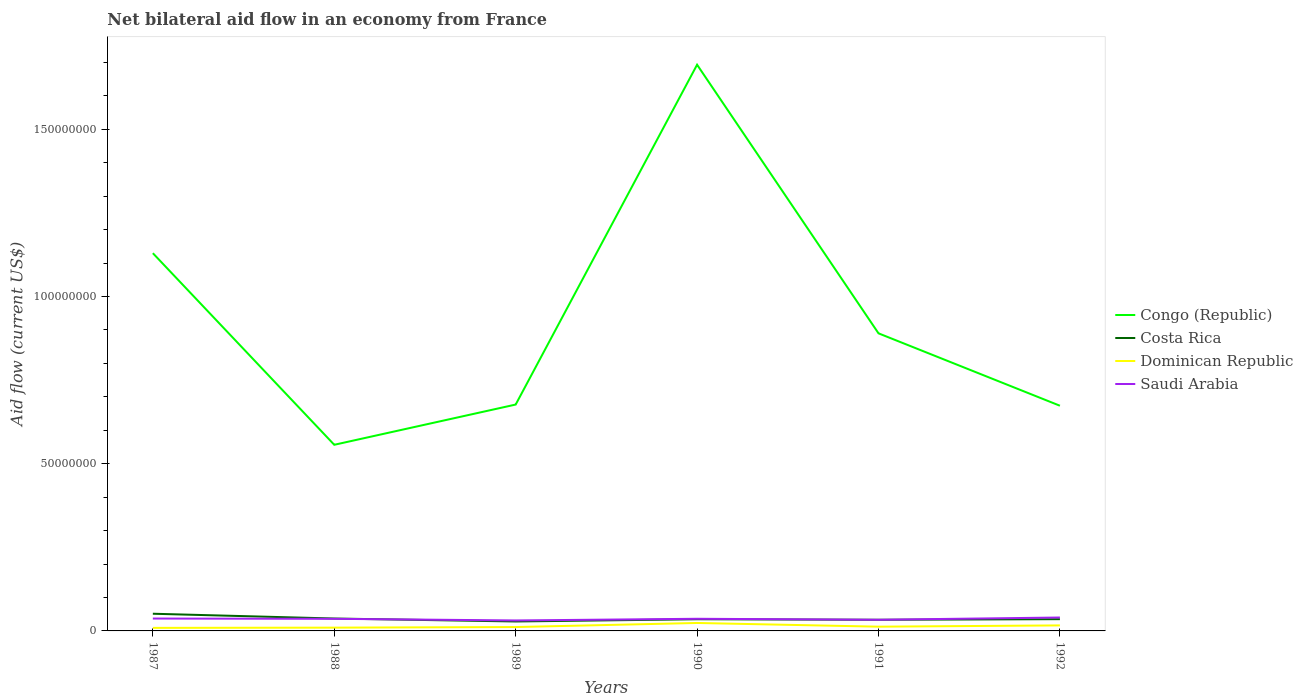Does the line corresponding to Dominican Republic intersect with the line corresponding to Costa Rica?
Keep it short and to the point. No. Across all years, what is the maximum net bilateral aid flow in Costa Rica?
Offer a terse response. 2.82e+06. What is the total net bilateral aid flow in Congo (Republic) in the graph?
Your answer should be very brief. 4.56e+07. What is the difference between the highest and the second highest net bilateral aid flow in Congo (Republic)?
Give a very brief answer. 1.14e+08. Is the net bilateral aid flow in Congo (Republic) strictly greater than the net bilateral aid flow in Costa Rica over the years?
Offer a terse response. No. How many years are there in the graph?
Offer a very short reply. 6. What is the difference between two consecutive major ticks on the Y-axis?
Provide a succinct answer. 5.00e+07. Are the values on the major ticks of Y-axis written in scientific E-notation?
Provide a succinct answer. No. Does the graph contain any zero values?
Make the answer very short. No. Does the graph contain grids?
Provide a succinct answer. No. How many legend labels are there?
Make the answer very short. 4. How are the legend labels stacked?
Offer a very short reply. Vertical. What is the title of the graph?
Your response must be concise. Net bilateral aid flow in an economy from France. What is the Aid flow (current US$) of Congo (Republic) in 1987?
Give a very brief answer. 1.13e+08. What is the Aid flow (current US$) in Costa Rica in 1987?
Ensure brevity in your answer.  5.14e+06. What is the Aid flow (current US$) in Dominican Republic in 1987?
Your answer should be compact. 9.10e+05. What is the Aid flow (current US$) of Saudi Arabia in 1987?
Provide a succinct answer. 3.70e+06. What is the Aid flow (current US$) of Congo (Republic) in 1988?
Give a very brief answer. 5.57e+07. What is the Aid flow (current US$) of Costa Rica in 1988?
Keep it short and to the point. 3.71e+06. What is the Aid flow (current US$) in Dominican Republic in 1988?
Make the answer very short. 9.80e+05. What is the Aid flow (current US$) of Saudi Arabia in 1988?
Offer a terse response. 3.62e+06. What is the Aid flow (current US$) of Congo (Republic) in 1989?
Ensure brevity in your answer.  6.77e+07. What is the Aid flow (current US$) of Costa Rica in 1989?
Your answer should be compact. 2.82e+06. What is the Aid flow (current US$) in Dominican Republic in 1989?
Offer a terse response. 1.16e+06. What is the Aid flow (current US$) of Saudi Arabia in 1989?
Your answer should be very brief. 3.13e+06. What is the Aid flow (current US$) of Congo (Republic) in 1990?
Your answer should be very brief. 1.69e+08. What is the Aid flow (current US$) of Costa Rica in 1990?
Offer a very short reply. 3.49e+06. What is the Aid flow (current US$) of Dominican Republic in 1990?
Provide a succinct answer. 2.38e+06. What is the Aid flow (current US$) of Saudi Arabia in 1990?
Provide a short and direct response. 3.63e+06. What is the Aid flow (current US$) in Congo (Republic) in 1991?
Your answer should be very brief. 8.90e+07. What is the Aid flow (current US$) of Costa Rica in 1991?
Provide a short and direct response. 3.33e+06. What is the Aid flow (current US$) of Dominican Republic in 1991?
Your response must be concise. 1.27e+06. What is the Aid flow (current US$) in Saudi Arabia in 1991?
Your response must be concise. 3.34e+06. What is the Aid flow (current US$) of Congo (Republic) in 1992?
Your response must be concise. 6.73e+07. What is the Aid flow (current US$) of Costa Rica in 1992?
Ensure brevity in your answer.  3.52e+06. What is the Aid flow (current US$) in Dominican Republic in 1992?
Keep it short and to the point. 1.65e+06. What is the Aid flow (current US$) of Saudi Arabia in 1992?
Your answer should be compact. 4.01e+06. Across all years, what is the maximum Aid flow (current US$) of Congo (Republic)?
Offer a very short reply. 1.69e+08. Across all years, what is the maximum Aid flow (current US$) of Costa Rica?
Provide a succinct answer. 5.14e+06. Across all years, what is the maximum Aid flow (current US$) of Dominican Republic?
Provide a succinct answer. 2.38e+06. Across all years, what is the maximum Aid flow (current US$) in Saudi Arabia?
Offer a terse response. 4.01e+06. Across all years, what is the minimum Aid flow (current US$) of Congo (Republic)?
Provide a succinct answer. 5.57e+07. Across all years, what is the minimum Aid flow (current US$) of Costa Rica?
Your response must be concise. 2.82e+06. Across all years, what is the minimum Aid flow (current US$) in Dominican Republic?
Ensure brevity in your answer.  9.10e+05. Across all years, what is the minimum Aid flow (current US$) in Saudi Arabia?
Provide a succinct answer. 3.13e+06. What is the total Aid flow (current US$) of Congo (Republic) in the graph?
Give a very brief answer. 5.62e+08. What is the total Aid flow (current US$) of Costa Rica in the graph?
Ensure brevity in your answer.  2.20e+07. What is the total Aid flow (current US$) in Dominican Republic in the graph?
Offer a terse response. 8.35e+06. What is the total Aid flow (current US$) in Saudi Arabia in the graph?
Ensure brevity in your answer.  2.14e+07. What is the difference between the Aid flow (current US$) of Congo (Republic) in 1987 and that in 1988?
Offer a terse response. 5.73e+07. What is the difference between the Aid flow (current US$) of Costa Rica in 1987 and that in 1988?
Provide a short and direct response. 1.43e+06. What is the difference between the Aid flow (current US$) of Saudi Arabia in 1987 and that in 1988?
Give a very brief answer. 8.00e+04. What is the difference between the Aid flow (current US$) in Congo (Republic) in 1987 and that in 1989?
Offer a very short reply. 4.53e+07. What is the difference between the Aid flow (current US$) of Costa Rica in 1987 and that in 1989?
Ensure brevity in your answer.  2.32e+06. What is the difference between the Aid flow (current US$) in Saudi Arabia in 1987 and that in 1989?
Offer a very short reply. 5.70e+05. What is the difference between the Aid flow (current US$) of Congo (Republic) in 1987 and that in 1990?
Your answer should be very brief. -5.64e+07. What is the difference between the Aid flow (current US$) of Costa Rica in 1987 and that in 1990?
Ensure brevity in your answer.  1.65e+06. What is the difference between the Aid flow (current US$) of Dominican Republic in 1987 and that in 1990?
Offer a very short reply. -1.47e+06. What is the difference between the Aid flow (current US$) of Congo (Republic) in 1987 and that in 1991?
Give a very brief answer. 2.40e+07. What is the difference between the Aid flow (current US$) of Costa Rica in 1987 and that in 1991?
Your answer should be very brief. 1.81e+06. What is the difference between the Aid flow (current US$) of Dominican Republic in 1987 and that in 1991?
Keep it short and to the point. -3.60e+05. What is the difference between the Aid flow (current US$) in Saudi Arabia in 1987 and that in 1991?
Offer a terse response. 3.60e+05. What is the difference between the Aid flow (current US$) in Congo (Republic) in 1987 and that in 1992?
Keep it short and to the point. 4.56e+07. What is the difference between the Aid flow (current US$) in Costa Rica in 1987 and that in 1992?
Provide a succinct answer. 1.62e+06. What is the difference between the Aid flow (current US$) in Dominican Republic in 1987 and that in 1992?
Your answer should be compact. -7.40e+05. What is the difference between the Aid flow (current US$) of Saudi Arabia in 1987 and that in 1992?
Give a very brief answer. -3.10e+05. What is the difference between the Aid flow (current US$) in Congo (Republic) in 1988 and that in 1989?
Provide a short and direct response. -1.20e+07. What is the difference between the Aid flow (current US$) in Costa Rica in 1988 and that in 1989?
Offer a terse response. 8.90e+05. What is the difference between the Aid flow (current US$) of Dominican Republic in 1988 and that in 1989?
Offer a terse response. -1.80e+05. What is the difference between the Aid flow (current US$) in Congo (Republic) in 1988 and that in 1990?
Give a very brief answer. -1.14e+08. What is the difference between the Aid flow (current US$) in Costa Rica in 1988 and that in 1990?
Make the answer very short. 2.20e+05. What is the difference between the Aid flow (current US$) of Dominican Republic in 1988 and that in 1990?
Provide a short and direct response. -1.40e+06. What is the difference between the Aid flow (current US$) of Congo (Republic) in 1988 and that in 1991?
Ensure brevity in your answer.  -3.33e+07. What is the difference between the Aid flow (current US$) in Congo (Republic) in 1988 and that in 1992?
Offer a terse response. -1.17e+07. What is the difference between the Aid flow (current US$) in Costa Rica in 1988 and that in 1992?
Your answer should be compact. 1.90e+05. What is the difference between the Aid flow (current US$) in Dominican Republic in 1988 and that in 1992?
Ensure brevity in your answer.  -6.70e+05. What is the difference between the Aid flow (current US$) in Saudi Arabia in 1988 and that in 1992?
Ensure brevity in your answer.  -3.90e+05. What is the difference between the Aid flow (current US$) of Congo (Republic) in 1989 and that in 1990?
Your answer should be compact. -1.02e+08. What is the difference between the Aid flow (current US$) of Costa Rica in 1989 and that in 1990?
Provide a short and direct response. -6.70e+05. What is the difference between the Aid flow (current US$) of Dominican Republic in 1989 and that in 1990?
Provide a short and direct response. -1.22e+06. What is the difference between the Aid flow (current US$) in Saudi Arabia in 1989 and that in 1990?
Provide a short and direct response. -5.00e+05. What is the difference between the Aid flow (current US$) of Congo (Republic) in 1989 and that in 1991?
Keep it short and to the point. -2.13e+07. What is the difference between the Aid flow (current US$) of Costa Rica in 1989 and that in 1991?
Offer a very short reply. -5.10e+05. What is the difference between the Aid flow (current US$) in Congo (Republic) in 1989 and that in 1992?
Make the answer very short. 3.50e+05. What is the difference between the Aid flow (current US$) of Costa Rica in 1989 and that in 1992?
Offer a terse response. -7.00e+05. What is the difference between the Aid flow (current US$) of Dominican Republic in 1989 and that in 1992?
Make the answer very short. -4.90e+05. What is the difference between the Aid flow (current US$) of Saudi Arabia in 1989 and that in 1992?
Your answer should be compact. -8.80e+05. What is the difference between the Aid flow (current US$) in Congo (Republic) in 1990 and that in 1991?
Keep it short and to the point. 8.03e+07. What is the difference between the Aid flow (current US$) in Dominican Republic in 1990 and that in 1991?
Provide a succinct answer. 1.11e+06. What is the difference between the Aid flow (current US$) of Congo (Republic) in 1990 and that in 1992?
Your response must be concise. 1.02e+08. What is the difference between the Aid flow (current US$) in Dominican Republic in 1990 and that in 1992?
Keep it short and to the point. 7.30e+05. What is the difference between the Aid flow (current US$) of Saudi Arabia in 1990 and that in 1992?
Your response must be concise. -3.80e+05. What is the difference between the Aid flow (current US$) in Congo (Republic) in 1991 and that in 1992?
Give a very brief answer. 2.16e+07. What is the difference between the Aid flow (current US$) in Costa Rica in 1991 and that in 1992?
Ensure brevity in your answer.  -1.90e+05. What is the difference between the Aid flow (current US$) of Dominican Republic in 1991 and that in 1992?
Keep it short and to the point. -3.80e+05. What is the difference between the Aid flow (current US$) in Saudi Arabia in 1991 and that in 1992?
Offer a terse response. -6.70e+05. What is the difference between the Aid flow (current US$) of Congo (Republic) in 1987 and the Aid flow (current US$) of Costa Rica in 1988?
Ensure brevity in your answer.  1.09e+08. What is the difference between the Aid flow (current US$) of Congo (Republic) in 1987 and the Aid flow (current US$) of Dominican Republic in 1988?
Give a very brief answer. 1.12e+08. What is the difference between the Aid flow (current US$) in Congo (Republic) in 1987 and the Aid flow (current US$) in Saudi Arabia in 1988?
Provide a short and direct response. 1.09e+08. What is the difference between the Aid flow (current US$) in Costa Rica in 1987 and the Aid flow (current US$) in Dominican Republic in 1988?
Ensure brevity in your answer.  4.16e+06. What is the difference between the Aid flow (current US$) of Costa Rica in 1987 and the Aid flow (current US$) of Saudi Arabia in 1988?
Your response must be concise. 1.52e+06. What is the difference between the Aid flow (current US$) of Dominican Republic in 1987 and the Aid flow (current US$) of Saudi Arabia in 1988?
Provide a succinct answer. -2.71e+06. What is the difference between the Aid flow (current US$) of Congo (Republic) in 1987 and the Aid flow (current US$) of Costa Rica in 1989?
Make the answer very short. 1.10e+08. What is the difference between the Aid flow (current US$) in Congo (Republic) in 1987 and the Aid flow (current US$) in Dominican Republic in 1989?
Keep it short and to the point. 1.12e+08. What is the difference between the Aid flow (current US$) in Congo (Republic) in 1987 and the Aid flow (current US$) in Saudi Arabia in 1989?
Offer a very short reply. 1.10e+08. What is the difference between the Aid flow (current US$) in Costa Rica in 1987 and the Aid flow (current US$) in Dominican Republic in 1989?
Your response must be concise. 3.98e+06. What is the difference between the Aid flow (current US$) in Costa Rica in 1987 and the Aid flow (current US$) in Saudi Arabia in 1989?
Ensure brevity in your answer.  2.01e+06. What is the difference between the Aid flow (current US$) in Dominican Republic in 1987 and the Aid flow (current US$) in Saudi Arabia in 1989?
Offer a terse response. -2.22e+06. What is the difference between the Aid flow (current US$) in Congo (Republic) in 1987 and the Aid flow (current US$) in Costa Rica in 1990?
Ensure brevity in your answer.  1.09e+08. What is the difference between the Aid flow (current US$) in Congo (Republic) in 1987 and the Aid flow (current US$) in Dominican Republic in 1990?
Give a very brief answer. 1.11e+08. What is the difference between the Aid flow (current US$) of Congo (Republic) in 1987 and the Aid flow (current US$) of Saudi Arabia in 1990?
Your response must be concise. 1.09e+08. What is the difference between the Aid flow (current US$) in Costa Rica in 1987 and the Aid flow (current US$) in Dominican Republic in 1990?
Your response must be concise. 2.76e+06. What is the difference between the Aid flow (current US$) in Costa Rica in 1987 and the Aid flow (current US$) in Saudi Arabia in 1990?
Your response must be concise. 1.51e+06. What is the difference between the Aid flow (current US$) of Dominican Republic in 1987 and the Aid flow (current US$) of Saudi Arabia in 1990?
Offer a terse response. -2.72e+06. What is the difference between the Aid flow (current US$) in Congo (Republic) in 1987 and the Aid flow (current US$) in Costa Rica in 1991?
Your answer should be very brief. 1.10e+08. What is the difference between the Aid flow (current US$) of Congo (Republic) in 1987 and the Aid flow (current US$) of Dominican Republic in 1991?
Your answer should be very brief. 1.12e+08. What is the difference between the Aid flow (current US$) in Congo (Republic) in 1987 and the Aid flow (current US$) in Saudi Arabia in 1991?
Make the answer very short. 1.10e+08. What is the difference between the Aid flow (current US$) of Costa Rica in 1987 and the Aid flow (current US$) of Dominican Republic in 1991?
Give a very brief answer. 3.87e+06. What is the difference between the Aid flow (current US$) in Costa Rica in 1987 and the Aid flow (current US$) in Saudi Arabia in 1991?
Ensure brevity in your answer.  1.80e+06. What is the difference between the Aid flow (current US$) of Dominican Republic in 1987 and the Aid flow (current US$) of Saudi Arabia in 1991?
Provide a short and direct response. -2.43e+06. What is the difference between the Aid flow (current US$) of Congo (Republic) in 1987 and the Aid flow (current US$) of Costa Rica in 1992?
Offer a very short reply. 1.09e+08. What is the difference between the Aid flow (current US$) of Congo (Republic) in 1987 and the Aid flow (current US$) of Dominican Republic in 1992?
Your answer should be compact. 1.11e+08. What is the difference between the Aid flow (current US$) in Congo (Republic) in 1987 and the Aid flow (current US$) in Saudi Arabia in 1992?
Provide a short and direct response. 1.09e+08. What is the difference between the Aid flow (current US$) of Costa Rica in 1987 and the Aid flow (current US$) of Dominican Republic in 1992?
Give a very brief answer. 3.49e+06. What is the difference between the Aid flow (current US$) of Costa Rica in 1987 and the Aid flow (current US$) of Saudi Arabia in 1992?
Your response must be concise. 1.13e+06. What is the difference between the Aid flow (current US$) in Dominican Republic in 1987 and the Aid flow (current US$) in Saudi Arabia in 1992?
Offer a terse response. -3.10e+06. What is the difference between the Aid flow (current US$) in Congo (Republic) in 1988 and the Aid flow (current US$) in Costa Rica in 1989?
Make the answer very short. 5.28e+07. What is the difference between the Aid flow (current US$) of Congo (Republic) in 1988 and the Aid flow (current US$) of Dominican Republic in 1989?
Offer a very short reply. 5.45e+07. What is the difference between the Aid flow (current US$) in Congo (Republic) in 1988 and the Aid flow (current US$) in Saudi Arabia in 1989?
Your response must be concise. 5.25e+07. What is the difference between the Aid flow (current US$) of Costa Rica in 1988 and the Aid flow (current US$) of Dominican Republic in 1989?
Provide a short and direct response. 2.55e+06. What is the difference between the Aid flow (current US$) of Costa Rica in 1988 and the Aid flow (current US$) of Saudi Arabia in 1989?
Give a very brief answer. 5.80e+05. What is the difference between the Aid flow (current US$) of Dominican Republic in 1988 and the Aid flow (current US$) of Saudi Arabia in 1989?
Your response must be concise. -2.15e+06. What is the difference between the Aid flow (current US$) of Congo (Republic) in 1988 and the Aid flow (current US$) of Costa Rica in 1990?
Ensure brevity in your answer.  5.22e+07. What is the difference between the Aid flow (current US$) of Congo (Republic) in 1988 and the Aid flow (current US$) of Dominican Republic in 1990?
Provide a short and direct response. 5.33e+07. What is the difference between the Aid flow (current US$) of Congo (Republic) in 1988 and the Aid flow (current US$) of Saudi Arabia in 1990?
Keep it short and to the point. 5.20e+07. What is the difference between the Aid flow (current US$) of Costa Rica in 1988 and the Aid flow (current US$) of Dominican Republic in 1990?
Offer a terse response. 1.33e+06. What is the difference between the Aid flow (current US$) in Dominican Republic in 1988 and the Aid flow (current US$) in Saudi Arabia in 1990?
Give a very brief answer. -2.65e+06. What is the difference between the Aid flow (current US$) of Congo (Republic) in 1988 and the Aid flow (current US$) of Costa Rica in 1991?
Your answer should be compact. 5.23e+07. What is the difference between the Aid flow (current US$) in Congo (Republic) in 1988 and the Aid flow (current US$) in Dominican Republic in 1991?
Provide a succinct answer. 5.44e+07. What is the difference between the Aid flow (current US$) of Congo (Republic) in 1988 and the Aid flow (current US$) of Saudi Arabia in 1991?
Your response must be concise. 5.23e+07. What is the difference between the Aid flow (current US$) of Costa Rica in 1988 and the Aid flow (current US$) of Dominican Republic in 1991?
Ensure brevity in your answer.  2.44e+06. What is the difference between the Aid flow (current US$) in Costa Rica in 1988 and the Aid flow (current US$) in Saudi Arabia in 1991?
Offer a very short reply. 3.70e+05. What is the difference between the Aid flow (current US$) of Dominican Republic in 1988 and the Aid flow (current US$) of Saudi Arabia in 1991?
Offer a terse response. -2.36e+06. What is the difference between the Aid flow (current US$) of Congo (Republic) in 1988 and the Aid flow (current US$) of Costa Rica in 1992?
Offer a very short reply. 5.21e+07. What is the difference between the Aid flow (current US$) in Congo (Republic) in 1988 and the Aid flow (current US$) in Dominican Republic in 1992?
Your answer should be very brief. 5.40e+07. What is the difference between the Aid flow (current US$) in Congo (Republic) in 1988 and the Aid flow (current US$) in Saudi Arabia in 1992?
Offer a very short reply. 5.16e+07. What is the difference between the Aid flow (current US$) of Costa Rica in 1988 and the Aid flow (current US$) of Dominican Republic in 1992?
Give a very brief answer. 2.06e+06. What is the difference between the Aid flow (current US$) of Dominican Republic in 1988 and the Aid flow (current US$) of Saudi Arabia in 1992?
Your response must be concise. -3.03e+06. What is the difference between the Aid flow (current US$) in Congo (Republic) in 1989 and the Aid flow (current US$) in Costa Rica in 1990?
Give a very brief answer. 6.42e+07. What is the difference between the Aid flow (current US$) in Congo (Republic) in 1989 and the Aid flow (current US$) in Dominican Republic in 1990?
Ensure brevity in your answer.  6.53e+07. What is the difference between the Aid flow (current US$) of Congo (Republic) in 1989 and the Aid flow (current US$) of Saudi Arabia in 1990?
Offer a terse response. 6.41e+07. What is the difference between the Aid flow (current US$) of Costa Rica in 1989 and the Aid flow (current US$) of Dominican Republic in 1990?
Offer a very short reply. 4.40e+05. What is the difference between the Aid flow (current US$) of Costa Rica in 1989 and the Aid flow (current US$) of Saudi Arabia in 1990?
Your response must be concise. -8.10e+05. What is the difference between the Aid flow (current US$) in Dominican Republic in 1989 and the Aid flow (current US$) in Saudi Arabia in 1990?
Your answer should be very brief. -2.47e+06. What is the difference between the Aid flow (current US$) of Congo (Republic) in 1989 and the Aid flow (current US$) of Costa Rica in 1991?
Your answer should be very brief. 6.44e+07. What is the difference between the Aid flow (current US$) of Congo (Republic) in 1989 and the Aid flow (current US$) of Dominican Republic in 1991?
Give a very brief answer. 6.64e+07. What is the difference between the Aid flow (current US$) of Congo (Republic) in 1989 and the Aid flow (current US$) of Saudi Arabia in 1991?
Offer a terse response. 6.44e+07. What is the difference between the Aid flow (current US$) of Costa Rica in 1989 and the Aid flow (current US$) of Dominican Republic in 1991?
Ensure brevity in your answer.  1.55e+06. What is the difference between the Aid flow (current US$) of Costa Rica in 1989 and the Aid flow (current US$) of Saudi Arabia in 1991?
Give a very brief answer. -5.20e+05. What is the difference between the Aid flow (current US$) in Dominican Republic in 1989 and the Aid flow (current US$) in Saudi Arabia in 1991?
Give a very brief answer. -2.18e+06. What is the difference between the Aid flow (current US$) of Congo (Republic) in 1989 and the Aid flow (current US$) of Costa Rica in 1992?
Give a very brief answer. 6.42e+07. What is the difference between the Aid flow (current US$) in Congo (Republic) in 1989 and the Aid flow (current US$) in Dominican Republic in 1992?
Ensure brevity in your answer.  6.60e+07. What is the difference between the Aid flow (current US$) in Congo (Republic) in 1989 and the Aid flow (current US$) in Saudi Arabia in 1992?
Offer a very short reply. 6.37e+07. What is the difference between the Aid flow (current US$) in Costa Rica in 1989 and the Aid flow (current US$) in Dominican Republic in 1992?
Your answer should be very brief. 1.17e+06. What is the difference between the Aid flow (current US$) in Costa Rica in 1989 and the Aid flow (current US$) in Saudi Arabia in 1992?
Provide a short and direct response. -1.19e+06. What is the difference between the Aid flow (current US$) in Dominican Republic in 1989 and the Aid flow (current US$) in Saudi Arabia in 1992?
Keep it short and to the point. -2.85e+06. What is the difference between the Aid flow (current US$) in Congo (Republic) in 1990 and the Aid flow (current US$) in Costa Rica in 1991?
Your response must be concise. 1.66e+08. What is the difference between the Aid flow (current US$) in Congo (Republic) in 1990 and the Aid flow (current US$) in Dominican Republic in 1991?
Your answer should be compact. 1.68e+08. What is the difference between the Aid flow (current US$) of Congo (Republic) in 1990 and the Aid flow (current US$) of Saudi Arabia in 1991?
Provide a short and direct response. 1.66e+08. What is the difference between the Aid flow (current US$) of Costa Rica in 1990 and the Aid flow (current US$) of Dominican Republic in 1991?
Your answer should be compact. 2.22e+06. What is the difference between the Aid flow (current US$) of Costa Rica in 1990 and the Aid flow (current US$) of Saudi Arabia in 1991?
Keep it short and to the point. 1.50e+05. What is the difference between the Aid flow (current US$) in Dominican Republic in 1990 and the Aid flow (current US$) in Saudi Arabia in 1991?
Your answer should be compact. -9.60e+05. What is the difference between the Aid flow (current US$) in Congo (Republic) in 1990 and the Aid flow (current US$) in Costa Rica in 1992?
Your answer should be very brief. 1.66e+08. What is the difference between the Aid flow (current US$) in Congo (Republic) in 1990 and the Aid flow (current US$) in Dominican Republic in 1992?
Keep it short and to the point. 1.68e+08. What is the difference between the Aid flow (current US$) of Congo (Republic) in 1990 and the Aid flow (current US$) of Saudi Arabia in 1992?
Offer a very short reply. 1.65e+08. What is the difference between the Aid flow (current US$) of Costa Rica in 1990 and the Aid flow (current US$) of Dominican Republic in 1992?
Make the answer very short. 1.84e+06. What is the difference between the Aid flow (current US$) of Costa Rica in 1990 and the Aid flow (current US$) of Saudi Arabia in 1992?
Offer a very short reply. -5.20e+05. What is the difference between the Aid flow (current US$) in Dominican Republic in 1990 and the Aid flow (current US$) in Saudi Arabia in 1992?
Offer a terse response. -1.63e+06. What is the difference between the Aid flow (current US$) in Congo (Republic) in 1991 and the Aid flow (current US$) in Costa Rica in 1992?
Offer a very short reply. 8.55e+07. What is the difference between the Aid flow (current US$) of Congo (Republic) in 1991 and the Aid flow (current US$) of Dominican Republic in 1992?
Ensure brevity in your answer.  8.73e+07. What is the difference between the Aid flow (current US$) in Congo (Republic) in 1991 and the Aid flow (current US$) in Saudi Arabia in 1992?
Offer a terse response. 8.50e+07. What is the difference between the Aid flow (current US$) of Costa Rica in 1991 and the Aid flow (current US$) of Dominican Republic in 1992?
Give a very brief answer. 1.68e+06. What is the difference between the Aid flow (current US$) in Costa Rica in 1991 and the Aid flow (current US$) in Saudi Arabia in 1992?
Offer a very short reply. -6.80e+05. What is the difference between the Aid flow (current US$) in Dominican Republic in 1991 and the Aid flow (current US$) in Saudi Arabia in 1992?
Ensure brevity in your answer.  -2.74e+06. What is the average Aid flow (current US$) of Congo (Republic) per year?
Your response must be concise. 9.37e+07. What is the average Aid flow (current US$) in Costa Rica per year?
Offer a terse response. 3.67e+06. What is the average Aid flow (current US$) of Dominican Republic per year?
Make the answer very short. 1.39e+06. What is the average Aid flow (current US$) of Saudi Arabia per year?
Offer a terse response. 3.57e+06. In the year 1987, what is the difference between the Aid flow (current US$) in Congo (Republic) and Aid flow (current US$) in Costa Rica?
Your answer should be very brief. 1.08e+08. In the year 1987, what is the difference between the Aid flow (current US$) in Congo (Republic) and Aid flow (current US$) in Dominican Republic?
Make the answer very short. 1.12e+08. In the year 1987, what is the difference between the Aid flow (current US$) in Congo (Republic) and Aid flow (current US$) in Saudi Arabia?
Your response must be concise. 1.09e+08. In the year 1987, what is the difference between the Aid flow (current US$) in Costa Rica and Aid flow (current US$) in Dominican Republic?
Provide a succinct answer. 4.23e+06. In the year 1987, what is the difference between the Aid flow (current US$) of Costa Rica and Aid flow (current US$) of Saudi Arabia?
Keep it short and to the point. 1.44e+06. In the year 1987, what is the difference between the Aid flow (current US$) of Dominican Republic and Aid flow (current US$) of Saudi Arabia?
Give a very brief answer. -2.79e+06. In the year 1988, what is the difference between the Aid flow (current US$) in Congo (Republic) and Aid flow (current US$) in Costa Rica?
Keep it short and to the point. 5.20e+07. In the year 1988, what is the difference between the Aid flow (current US$) in Congo (Republic) and Aid flow (current US$) in Dominican Republic?
Provide a short and direct response. 5.47e+07. In the year 1988, what is the difference between the Aid flow (current US$) in Congo (Republic) and Aid flow (current US$) in Saudi Arabia?
Give a very brief answer. 5.20e+07. In the year 1988, what is the difference between the Aid flow (current US$) of Costa Rica and Aid flow (current US$) of Dominican Republic?
Keep it short and to the point. 2.73e+06. In the year 1988, what is the difference between the Aid flow (current US$) of Dominican Republic and Aid flow (current US$) of Saudi Arabia?
Ensure brevity in your answer.  -2.64e+06. In the year 1989, what is the difference between the Aid flow (current US$) in Congo (Republic) and Aid flow (current US$) in Costa Rica?
Your answer should be very brief. 6.49e+07. In the year 1989, what is the difference between the Aid flow (current US$) in Congo (Republic) and Aid flow (current US$) in Dominican Republic?
Provide a short and direct response. 6.65e+07. In the year 1989, what is the difference between the Aid flow (current US$) of Congo (Republic) and Aid flow (current US$) of Saudi Arabia?
Your answer should be compact. 6.46e+07. In the year 1989, what is the difference between the Aid flow (current US$) in Costa Rica and Aid flow (current US$) in Dominican Republic?
Make the answer very short. 1.66e+06. In the year 1989, what is the difference between the Aid flow (current US$) of Costa Rica and Aid flow (current US$) of Saudi Arabia?
Provide a short and direct response. -3.10e+05. In the year 1989, what is the difference between the Aid flow (current US$) of Dominican Republic and Aid flow (current US$) of Saudi Arabia?
Ensure brevity in your answer.  -1.97e+06. In the year 1990, what is the difference between the Aid flow (current US$) of Congo (Republic) and Aid flow (current US$) of Costa Rica?
Provide a succinct answer. 1.66e+08. In the year 1990, what is the difference between the Aid flow (current US$) of Congo (Republic) and Aid flow (current US$) of Dominican Republic?
Provide a succinct answer. 1.67e+08. In the year 1990, what is the difference between the Aid flow (current US$) in Congo (Republic) and Aid flow (current US$) in Saudi Arabia?
Provide a succinct answer. 1.66e+08. In the year 1990, what is the difference between the Aid flow (current US$) of Costa Rica and Aid flow (current US$) of Dominican Republic?
Make the answer very short. 1.11e+06. In the year 1990, what is the difference between the Aid flow (current US$) of Costa Rica and Aid flow (current US$) of Saudi Arabia?
Offer a terse response. -1.40e+05. In the year 1990, what is the difference between the Aid flow (current US$) in Dominican Republic and Aid flow (current US$) in Saudi Arabia?
Ensure brevity in your answer.  -1.25e+06. In the year 1991, what is the difference between the Aid flow (current US$) of Congo (Republic) and Aid flow (current US$) of Costa Rica?
Offer a terse response. 8.57e+07. In the year 1991, what is the difference between the Aid flow (current US$) of Congo (Republic) and Aid flow (current US$) of Dominican Republic?
Make the answer very short. 8.77e+07. In the year 1991, what is the difference between the Aid flow (current US$) of Congo (Republic) and Aid flow (current US$) of Saudi Arabia?
Keep it short and to the point. 8.56e+07. In the year 1991, what is the difference between the Aid flow (current US$) of Costa Rica and Aid flow (current US$) of Dominican Republic?
Keep it short and to the point. 2.06e+06. In the year 1991, what is the difference between the Aid flow (current US$) in Costa Rica and Aid flow (current US$) in Saudi Arabia?
Give a very brief answer. -10000. In the year 1991, what is the difference between the Aid flow (current US$) in Dominican Republic and Aid flow (current US$) in Saudi Arabia?
Provide a short and direct response. -2.07e+06. In the year 1992, what is the difference between the Aid flow (current US$) in Congo (Republic) and Aid flow (current US$) in Costa Rica?
Keep it short and to the point. 6.38e+07. In the year 1992, what is the difference between the Aid flow (current US$) in Congo (Republic) and Aid flow (current US$) in Dominican Republic?
Provide a succinct answer. 6.57e+07. In the year 1992, what is the difference between the Aid flow (current US$) in Congo (Republic) and Aid flow (current US$) in Saudi Arabia?
Ensure brevity in your answer.  6.33e+07. In the year 1992, what is the difference between the Aid flow (current US$) in Costa Rica and Aid flow (current US$) in Dominican Republic?
Ensure brevity in your answer.  1.87e+06. In the year 1992, what is the difference between the Aid flow (current US$) in Costa Rica and Aid flow (current US$) in Saudi Arabia?
Your answer should be compact. -4.90e+05. In the year 1992, what is the difference between the Aid flow (current US$) in Dominican Republic and Aid flow (current US$) in Saudi Arabia?
Offer a very short reply. -2.36e+06. What is the ratio of the Aid flow (current US$) of Congo (Republic) in 1987 to that in 1988?
Make the answer very short. 2.03. What is the ratio of the Aid flow (current US$) in Costa Rica in 1987 to that in 1988?
Provide a short and direct response. 1.39. What is the ratio of the Aid flow (current US$) in Dominican Republic in 1987 to that in 1988?
Your answer should be very brief. 0.93. What is the ratio of the Aid flow (current US$) of Saudi Arabia in 1987 to that in 1988?
Make the answer very short. 1.02. What is the ratio of the Aid flow (current US$) of Congo (Republic) in 1987 to that in 1989?
Ensure brevity in your answer.  1.67. What is the ratio of the Aid flow (current US$) of Costa Rica in 1987 to that in 1989?
Offer a very short reply. 1.82. What is the ratio of the Aid flow (current US$) of Dominican Republic in 1987 to that in 1989?
Offer a terse response. 0.78. What is the ratio of the Aid flow (current US$) in Saudi Arabia in 1987 to that in 1989?
Offer a very short reply. 1.18. What is the ratio of the Aid flow (current US$) in Congo (Republic) in 1987 to that in 1990?
Provide a short and direct response. 0.67. What is the ratio of the Aid flow (current US$) in Costa Rica in 1987 to that in 1990?
Give a very brief answer. 1.47. What is the ratio of the Aid flow (current US$) of Dominican Republic in 1987 to that in 1990?
Keep it short and to the point. 0.38. What is the ratio of the Aid flow (current US$) of Saudi Arabia in 1987 to that in 1990?
Offer a very short reply. 1.02. What is the ratio of the Aid flow (current US$) of Congo (Republic) in 1987 to that in 1991?
Provide a succinct answer. 1.27. What is the ratio of the Aid flow (current US$) in Costa Rica in 1987 to that in 1991?
Your response must be concise. 1.54. What is the ratio of the Aid flow (current US$) of Dominican Republic in 1987 to that in 1991?
Offer a very short reply. 0.72. What is the ratio of the Aid flow (current US$) of Saudi Arabia in 1987 to that in 1991?
Make the answer very short. 1.11. What is the ratio of the Aid flow (current US$) of Congo (Republic) in 1987 to that in 1992?
Offer a very short reply. 1.68. What is the ratio of the Aid flow (current US$) in Costa Rica in 1987 to that in 1992?
Give a very brief answer. 1.46. What is the ratio of the Aid flow (current US$) in Dominican Republic in 1987 to that in 1992?
Make the answer very short. 0.55. What is the ratio of the Aid flow (current US$) in Saudi Arabia in 1987 to that in 1992?
Keep it short and to the point. 0.92. What is the ratio of the Aid flow (current US$) in Congo (Republic) in 1988 to that in 1989?
Give a very brief answer. 0.82. What is the ratio of the Aid flow (current US$) in Costa Rica in 1988 to that in 1989?
Make the answer very short. 1.32. What is the ratio of the Aid flow (current US$) in Dominican Republic in 1988 to that in 1989?
Ensure brevity in your answer.  0.84. What is the ratio of the Aid flow (current US$) of Saudi Arabia in 1988 to that in 1989?
Provide a short and direct response. 1.16. What is the ratio of the Aid flow (current US$) of Congo (Republic) in 1988 to that in 1990?
Your answer should be compact. 0.33. What is the ratio of the Aid flow (current US$) of Costa Rica in 1988 to that in 1990?
Keep it short and to the point. 1.06. What is the ratio of the Aid flow (current US$) in Dominican Republic in 1988 to that in 1990?
Ensure brevity in your answer.  0.41. What is the ratio of the Aid flow (current US$) of Congo (Republic) in 1988 to that in 1991?
Your answer should be very brief. 0.63. What is the ratio of the Aid flow (current US$) of Costa Rica in 1988 to that in 1991?
Your response must be concise. 1.11. What is the ratio of the Aid flow (current US$) in Dominican Republic in 1988 to that in 1991?
Provide a short and direct response. 0.77. What is the ratio of the Aid flow (current US$) of Saudi Arabia in 1988 to that in 1991?
Ensure brevity in your answer.  1.08. What is the ratio of the Aid flow (current US$) in Congo (Republic) in 1988 to that in 1992?
Provide a short and direct response. 0.83. What is the ratio of the Aid flow (current US$) in Costa Rica in 1988 to that in 1992?
Keep it short and to the point. 1.05. What is the ratio of the Aid flow (current US$) in Dominican Republic in 1988 to that in 1992?
Offer a terse response. 0.59. What is the ratio of the Aid flow (current US$) of Saudi Arabia in 1988 to that in 1992?
Your answer should be compact. 0.9. What is the ratio of the Aid flow (current US$) in Congo (Republic) in 1989 to that in 1990?
Provide a succinct answer. 0.4. What is the ratio of the Aid flow (current US$) of Costa Rica in 1989 to that in 1990?
Your response must be concise. 0.81. What is the ratio of the Aid flow (current US$) in Dominican Republic in 1989 to that in 1990?
Your answer should be very brief. 0.49. What is the ratio of the Aid flow (current US$) in Saudi Arabia in 1989 to that in 1990?
Your answer should be very brief. 0.86. What is the ratio of the Aid flow (current US$) in Congo (Republic) in 1989 to that in 1991?
Your answer should be very brief. 0.76. What is the ratio of the Aid flow (current US$) in Costa Rica in 1989 to that in 1991?
Give a very brief answer. 0.85. What is the ratio of the Aid flow (current US$) in Dominican Republic in 1989 to that in 1991?
Give a very brief answer. 0.91. What is the ratio of the Aid flow (current US$) in Saudi Arabia in 1989 to that in 1991?
Offer a terse response. 0.94. What is the ratio of the Aid flow (current US$) of Congo (Republic) in 1989 to that in 1992?
Make the answer very short. 1.01. What is the ratio of the Aid flow (current US$) of Costa Rica in 1989 to that in 1992?
Your response must be concise. 0.8. What is the ratio of the Aid flow (current US$) of Dominican Republic in 1989 to that in 1992?
Provide a short and direct response. 0.7. What is the ratio of the Aid flow (current US$) of Saudi Arabia in 1989 to that in 1992?
Give a very brief answer. 0.78. What is the ratio of the Aid flow (current US$) in Congo (Republic) in 1990 to that in 1991?
Give a very brief answer. 1.9. What is the ratio of the Aid flow (current US$) of Costa Rica in 1990 to that in 1991?
Ensure brevity in your answer.  1.05. What is the ratio of the Aid flow (current US$) in Dominican Republic in 1990 to that in 1991?
Provide a succinct answer. 1.87. What is the ratio of the Aid flow (current US$) in Saudi Arabia in 1990 to that in 1991?
Keep it short and to the point. 1.09. What is the ratio of the Aid flow (current US$) of Congo (Republic) in 1990 to that in 1992?
Offer a very short reply. 2.51. What is the ratio of the Aid flow (current US$) of Costa Rica in 1990 to that in 1992?
Offer a terse response. 0.99. What is the ratio of the Aid flow (current US$) in Dominican Republic in 1990 to that in 1992?
Offer a terse response. 1.44. What is the ratio of the Aid flow (current US$) of Saudi Arabia in 1990 to that in 1992?
Make the answer very short. 0.91. What is the ratio of the Aid flow (current US$) in Congo (Republic) in 1991 to that in 1992?
Make the answer very short. 1.32. What is the ratio of the Aid flow (current US$) of Costa Rica in 1991 to that in 1992?
Offer a terse response. 0.95. What is the ratio of the Aid flow (current US$) of Dominican Republic in 1991 to that in 1992?
Ensure brevity in your answer.  0.77. What is the ratio of the Aid flow (current US$) of Saudi Arabia in 1991 to that in 1992?
Keep it short and to the point. 0.83. What is the difference between the highest and the second highest Aid flow (current US$) in Congo (Republic)?
Offer a terse response. 5.64e+07. What is the difference between the highest and the second highest Aid flow (current US$) of Costa Rica?
Your response must be concise. 1.43e+06. What is the difference between the highest and the second highest Aid flow (current US$) of Dominican Republic?
Ensure brevity in your answer.  7.30e+05. What is the difference between the highest and the second highest Aid flow (current US$) in Saudi Arabia?
Ensure brevity in your answer.  3.10e+05. What is the difference between the highest and the lowest Aid flow (current US$) in Congo (Republic)?
Ensure brevity in your answer.  1.14e+08. What is the difference between the highest and the lowest Aid flow (current US$) of Costa Rica?
Provide a succinct answer. 2.32e+06. What is the difference between the highest and the lowest Aid flow (current US$) in Dominican Republic?
Your answer should be compact. 1.47e+06. What is the difference between the highest and the lowest Aid flow (current US$) in Saudi Arabia?
Provide a succinct answer. 8.80e+05. 